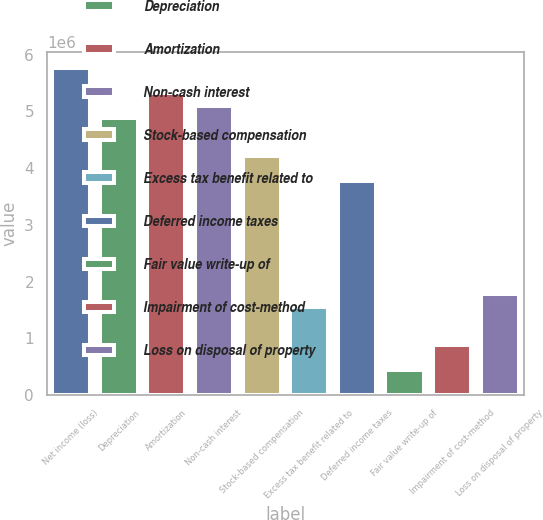Convert chart. <chart><loc_0><loc_0><loc_500><loc_500><bar_chart><fcel>Net income (loss)<fcel>Depreciation<fcel>Amortization<fcel>Non-cash interest<fcel>Stock-based compensation<fcel>Excess tax benefit related to<fcel>Deferred income taxes<fcel>Fair value write-up of<fcel>Impairment of cost-method<fcel>Loss on disposal of property<nl><fcel>5.76239e+06<fcel>4.87595e+06<fcel>5.31917e+06<fcel>5.09756e+06<fcel>4.21112e+06<fcel>1.55181e+06<fcel>3.76791e+06<fcel>443768<fcel>886987<fcel>1.77342e+06<nl></chart> 